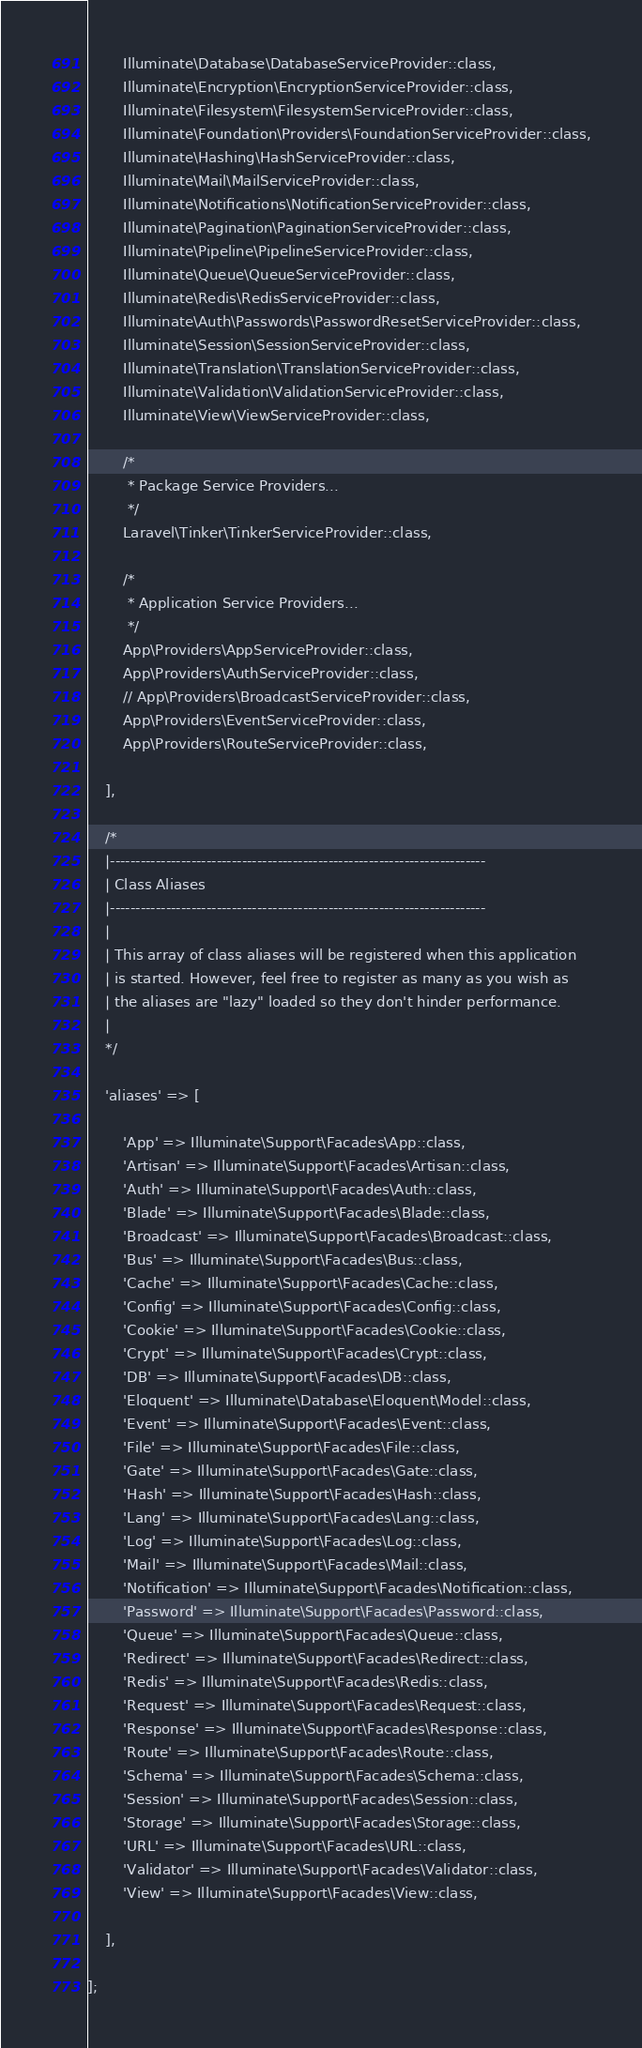Convert code to text. <code><loc_0><loc_0><loc_500><loc_500><_PHP_>        Illuminate\Database\DatabaseServiceProvider::class,
        Illuminate\Encryption\EncryptionServiceProvider::class,
        Illuminate\Filesystem\FilesystemServiceProvider::class,
        Illuminate\Foundation\Providers\FoundationServiceProvider::class,
        Illuminate\Hashing\HashServiceProvider::class,
        Illuminate\Mail\MailServiceProvider::class,
        Illuminate\Notifications\NotificationServiceProvider::class,
        Illuminate\Pagination\PaginationServiceProvider::class,
        Illuminate\Pipeline\PipelineServiceProvider::class,
        Illuminate\Queue\QueueServiceProvider::class,
        Illuminate\Redis\RedisServiceProvider::class,
        Illuminate\Auth\Passwords\PasswordResetServiceProvider::class,
        Illuminate\Session\SessionServiceProvider::class,
        Illuminate\Translation\TranslationServiceProvider::class,
        Illuminate\Validation\ValidationServiceProvider::class,
        Illuminate\View\ViewServiceProvider::class,

        /*
         * Package Service Providers...
         */
        Laravel\Tinker\TinkerServiceProvider::class,

        /*
         * Application Service Providers...
         */
        App\Providers\AppServiceProvider::class,
        App\Providers\AuthServiceProvider::class,
        // App\Providers\BroadcastServiceProvider::class,
        App\Providers\EventServiceProvider::class,
        App\Providers\RouteServiceProvider::class,

    ],

    /*
    |--------------------------------------------------------------------------
    | Class Aliases
    |--------------------------------------------------------------------------
    |
    | This array of class aliases will be registered when this application
    | is started. However, feel free to register as many as you wish as
    | the aliases are "lazy" loaded so they don't hinder performance.
    |
    */

    'aliases' => [

        'App' => Illuminate\Support\Facades\App::class,
        'Artisan' => Illuminate\Support\Facades\Artisan::class,
        'Auth' => Illuminate\Support\Facades\Auth::class,
        'Blade' => Illuminate\Support\Facades\Blade::class,
        'Broadcast' => Illuminate\Support\Facades\Broadcast::class,
        'Bus' => Illuminate\Support\Facades\Bus::class,
        'Cache' => Illuminate\Support\Facades\Cache::class,
        'Config' => Illuminate\Support\Facades\Config::class,
        'Cookie' => Illuminate\Support\Facades\Cookie::class,
        'Crypt' => Illuminate\Support\Facades\Crypt::class,
        'DB' => Illuminate\Support\Facades\DB::class,
        'Eloquent' => Illuminate\Database\Eloquent\Model::class,
        'Event' => Illuminate\Support\Facades\Event::class,
        'File' => Illuminate\Support\Facades\File::class,
        'Gate' => Illuminate\Support\Facades\Gate::class,
        'Hash' => Illuminate\Support\Facades\Hash::class,
        'Lang' => Illuminate\Support\Facades\Lang::class,
        'Log' => Illuminate\Support\Facades\Log::class,
        'Mail' => Illuminate\Support\Facades\Mail::class,
        'Notification' => Illuminate\Support\Facades\Notification::class,
        'Password' => Illuminate\Support\Facades\Password::class,
        'Queue' => Illuminate\Support\Facades\Queue::class,
        'Redirect' => Illuminate\Support\Facades\Redirect::class,
        'Redis' => Illuminate\Support\Facades\Redis::class,
        'Request' => Illuminate\Support\Facades\Request::class,
        'Response' => Illuminate\Support\Facades\Response::class,
        'Route' => Illuminate\Support\Facades\Route::class,
        'Schema' => Illuminate\Support\Facades\Schema::class,
        'Session' => Illuminate\Support\Facades\Session::class,
        'Storage' => Illuminate\Support\Facades\Storage::class,
        'URL' => Illuminate\Support\Facades\URL::class,
        'Validator' => Illuminate\Support\Facades\Validator::class,
        'View' => Illuminate\Support\Facades\View::class,

    ],

];
</code> 